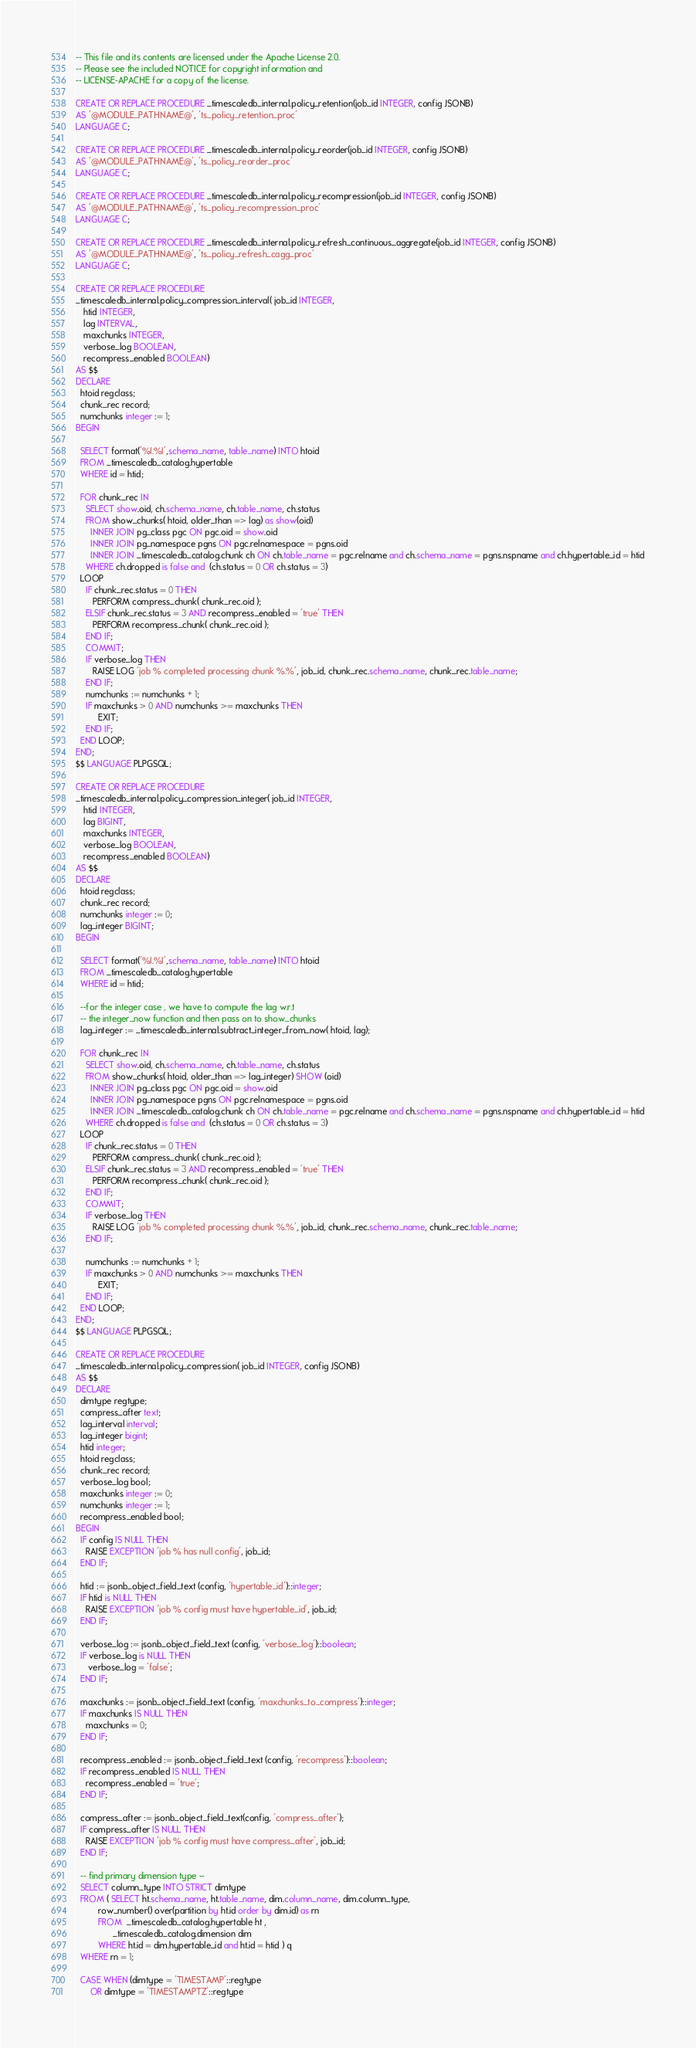Convert code to text. <code><loc_0><loc_0><loc_500><loc_500><_SQL_>-- This file and its contents are licensed under the Apache License 2.0.
-- Please see the included NOTICE for copyright information and
-- LICENSE-APACHE for a copy of the license.

CREATE OR REPLACE PROCEDURE _timescaledb_internal.policy_retention(job_id INTEGER, config JSONB)
AS '@MODULE_PATHNAME@', 'ts_policy_retention_proc'
LANGUAGE C;

CREATE OR REPLACE PROCEDURE _timescaledb_internal.policy_reorder(job_id INTEGER, config JSONB)
AS '@MODULE_PATHNAME@', 'ts_policy_reorder_proc'
LANGUAGE C;

CREATE OR REPLACE PROCEDURE _timescaledb_internal.policy_recompression(job_id INTEGER, config JSONB)
AS '@MODULE_PATHNAME@', 'ts_policy_recompression_proc'
LANGUAGE C;

CREATE OR REPLACE PROCEDURE _timescaledb_internal.policy_refresh_continuous_aggregate(job_id INTEGER, config JSONB)
AS '@MODULE_PATHNAME@', 'ts_policy_refresh_cagg_proc'
LANGUAGE C;

CREATE OR REPLACE PROCEDURE
_timescaledb_internal.policy_compression_interval( job_id INTEGER, 
   htid INTEGER,
   lag INTERVAL,
   maxchunks INTEGER,
   verbose_log BOOLEAN,
   recompress_enabled BOOLEAN)
AS $$
DECLARE
  htoid regclass;
  chunk_rec record;
  numchunks integer := 1;
BEGIN

  SELECT format('%I.%I',schema_name, table_name) INTO htoid
  FROM _timescaledb_catalog.hypertable
  WHERE id = htid;

  FOR chunk_rec IN
    SELECT show.oid, ch.schema_name, ch.table_name, ch.status
    FROM show_chunks( htoid, older_than => lag) as show(oid)
      INNER JOIN pg_class pgc ON pgc.oid = show.oid
      INNER JOIN pg_namespace pgns ON pgc.relnamespace = pgns.oid
      INNER JOIN _timescaledb_catalog.chunk ch ON ch.table_name = pgc.relname and ch.schema_name = pgns.nspname and ch.hypertable_id = htid
    WHERE ch.dropped is false and  (ch.status = 0 OR ch.status = 3)
  LOOP
    IF chunk_rec.status = 0 THEN
       PERFORM compress_chunk( chunk_rec.oid );
    ELSIF chunk_rec.status = 3 AND recompress_enabled = 'true' THEN
       PERFORM recompress_chunk( chunk_rec.oid );
    END IF;
    COMMIT;
    IF verbose_log THEN
       RAISE LOG 'job % completed processing chunk %.%', job_id, chunk_rec.schema_name, chunk_rec.table_name;
    END IF;
    numchunks := numchunks + 1;
    IF maxchunks > 0 AND numchunks >= maxchunks THEN  
         EXIT; 
    END IF;  
  END LOOP;
END;
$$ LANGUAGE PLPGSQL;

CREATE OR REPLACE PROCEDURE
_timescaledb_internal.policy_compression_integer( job_id INTEGER, 
   htid INTEGER,
   lag BIGINT,
   maxchunks INTEGER,
   verbose_log BOOLEAN,
   recompress_enabled BOOLEAN)
AS $$
DECLARE
  htoid regclass;
  chunk_rec record;
  numchunks integer := 0;
  lag_integer BIGINT;
BEGIN

  SELECT format('%I.%I',schema_name, table_name) INTO htoid
  FROM _timescaledb_catalog.hypertable
  WHERE id = htid;

  --for the integer case , we have to compute the lag w.r.t 
  -- the integer_now function and then pass on to show_chunks
  lag_integer := _timescaledb_internal.subtract_integer_from_now( htoid, lag);

  FOR chunk_rec IN
    SELECT show.oid, ch.schema_name, ch.table_name, ch.status
    FROM show_chunks( htoid, older_than => lag_integer) SHOW (oid)
      INNER JOIN pg_class pgc ON pgc.oid = show.oid
      INNER JOIN pg_namespace pgns ON pgc.relnamespace = pgns.oid
      INNER JOIN _timescaledb_catalog.chunk ch ON ch.table_name = pgc.relname and ch.schema_name = pgns.nspname and ch.hypertable_id = htid
    WHERE ch.dropped is false and  (ch.status = 0 OR ch.status = 3)
  LOOP
    IF chunk_rec.status = 0 THEN
       PERFORM compress_chunk( chunk_rec.oid );
    ELSIF chunk_rec.status = 3 AND recompress_enabled = 'true' THEN
       PERFORM recompress_chunk( chunk_rec.oid );
    END IF;
    COMMIT;
    IF verbose_log THEN
       RAISE LOG 'job % completed processing chunk %.%', job_id, chunk_rec.schema_name, chunk_rec.table_name;
    END IF;

    numchunks := numchunks + 1;
    IF maxchunks > 0 AND numchunks >= maxchunks THEN  
         EXIT; 
    END IF;  
  END LOOP;
END;
$$ LANGUAGE PLPGSQL;

CREATE OR REPLACE PROCEDURE
_timescaledb_internal.policy_compression( job_id INTEGER, config JSONB)
AS $$
DECLARE
  dimtype regtype;
  compress_after text;
  lag_interval interval;
  lag_integer bigint;
  htid integer;
  htoid regclass;
  chunk_rec record;
  verbose_log bool;
  maxchunks integer := 0;
  numchunks integer := 1;
  recompress_enabled bool;
BEGIN
  IF config IS NULL THEN
    RAISE EXCEPTION 'job % has null config', job_id;
  END IF;
 
  htid := jsonb_object_field_text (config, 'hypertable_id')::integer;
  IF htid is NULL THEN
    RAISE EXCEPTION 'job % config must have hypertable_id', job_id;
  END IF;
  
  verbose_log := jsonb_object_field_text (config, 'verbose_log')::boolean;
  IF verbose_log is NULL THEN
     verbose_log = 'false';
  END IF;
  
  maxchunks := jsonb_object_field_text (config, 'maxchunks_to_compress')::integer;
  IF maxchunks IS NULL THEN
    maxchunks = 0;
  END IF;
  
  recompress_enabled := jsonb_object_field_text (config, 'recompress')::boolean;
  IF recompress_enabled IS NULL THEN
    recompress_enabled = 'true';
  END IF;
  
  compress_after := jsonb_object_field_text(config, 'compress_after');
  IF compress_after IS NULL THEN
    RAISE EXCEPTION 'job % config must have compress_after', job_id;
  END IF;

  -- find primary dimension type --
  SELECT column_type INTO STRICT dimtype
  FROM ( SELECT ht.schema_name, ht.table_name, dim.column_name, dim.column_type,
         row_number() over(partition by ht.id order by dim.id) as rn
         FROM  _timescaledb_catalog.hypertable ht , 
               _timescaledb_catalog.dimension dim 
         WHERE ht.id = dim.hypertable_id and ht.id = htid ) q 
  WHERE rn = 1; 
 
  CASE WHEN (dimtype = 'TIMESTAMP'::regtype
      OR dimtype = 'TIMESTAMPTZ'::regtype</code> 